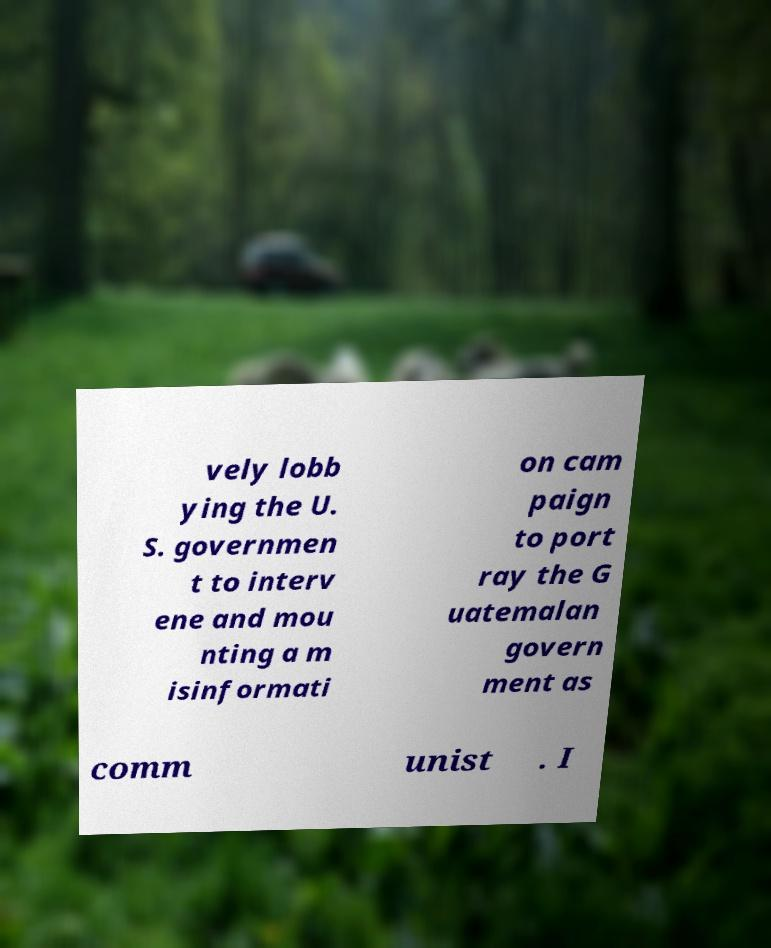Can you read and provide the text displayed in the image?This photo seems to have some interesting text. Can you extract and type it out for me? vely lobb ying the U. S. governmen t to interv ene and mou nting a m isinformati on cam paign to port ray the G uatemalan govern ment as comm unist . I 